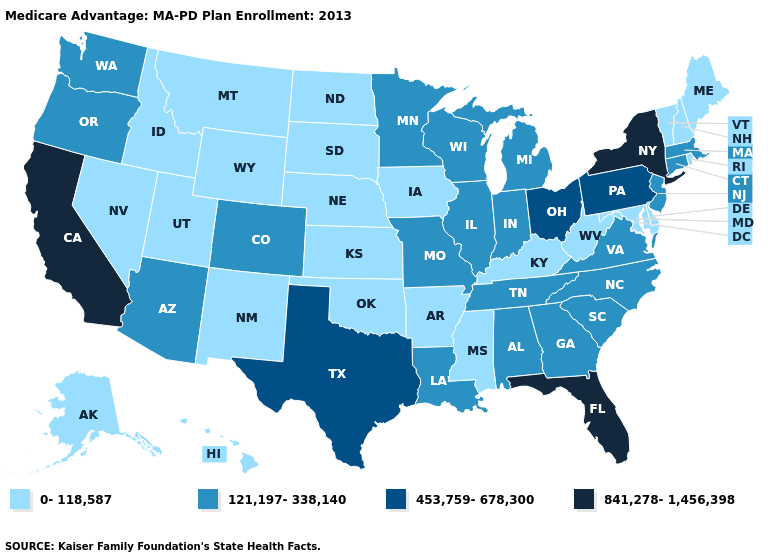What is the highest value in states that border Nevada?
Write a very short answer. 841,278-1,456,398. Name the states that have a value in the range 0-118,587?
Keep it brief. Alaska, Arkansas, Delaware, Hawaii, Iowa, Idaho, Kansas, Kentucky, Maryland, Maine, Mississippi, Montana, North Dakota, Nebraska, New Hampshire, New Mexico, Nevada, Oklahoma, Rhode Island, South Dakota, Utah, Vermont, West Virginia, Wyoming. How many symbols are there in the legend?
Answer briefly. 4. Among the states that border Washington , does Oregon have the lowest value?
Answer briefly. No. Does Wyoming have a lower value than Arizona?
Quick response, please. Yes. What is the value of Iowa?
Give a very brief answer. 0-118,587. Does the first symbol in the legend represent the smallest category?
Concise answer only. Yes. Name the states that have a value in the range 453,759-678,300?
Write a very short answer. Ohio, Pennsylvania, Texas. Name the states that have a value in the range 0-118,587?
Concise answer only. Alaska, Arkansas, Delaware, Hawaii, Iowa, Idaho, Kansas, Kentucky, Maryland, Maine, Mississippi, Montana, North Dakota, Nebraska, New Hampshire, New Mexico, Nevada, Oklahoma, Rhode Island, South Dakota, Utah, Vermont, West Virginia, Wyoming. Does Oklahoma have the lowest value in the South?
Be succinct. Yes. What is the value of New Mexico?
Give a very brief answer. 0-118,587. What is the value of Ohio?
Answer briefly. 453,759-678,300. What is the value of Alaska?
Give a very brief answer. 0-118,587. Does the map have missing data?
Concise answer only. No. Name the states that have a value in the range 841,278-1,456,398?
Give a very brief answer. California, Florida, New York. 